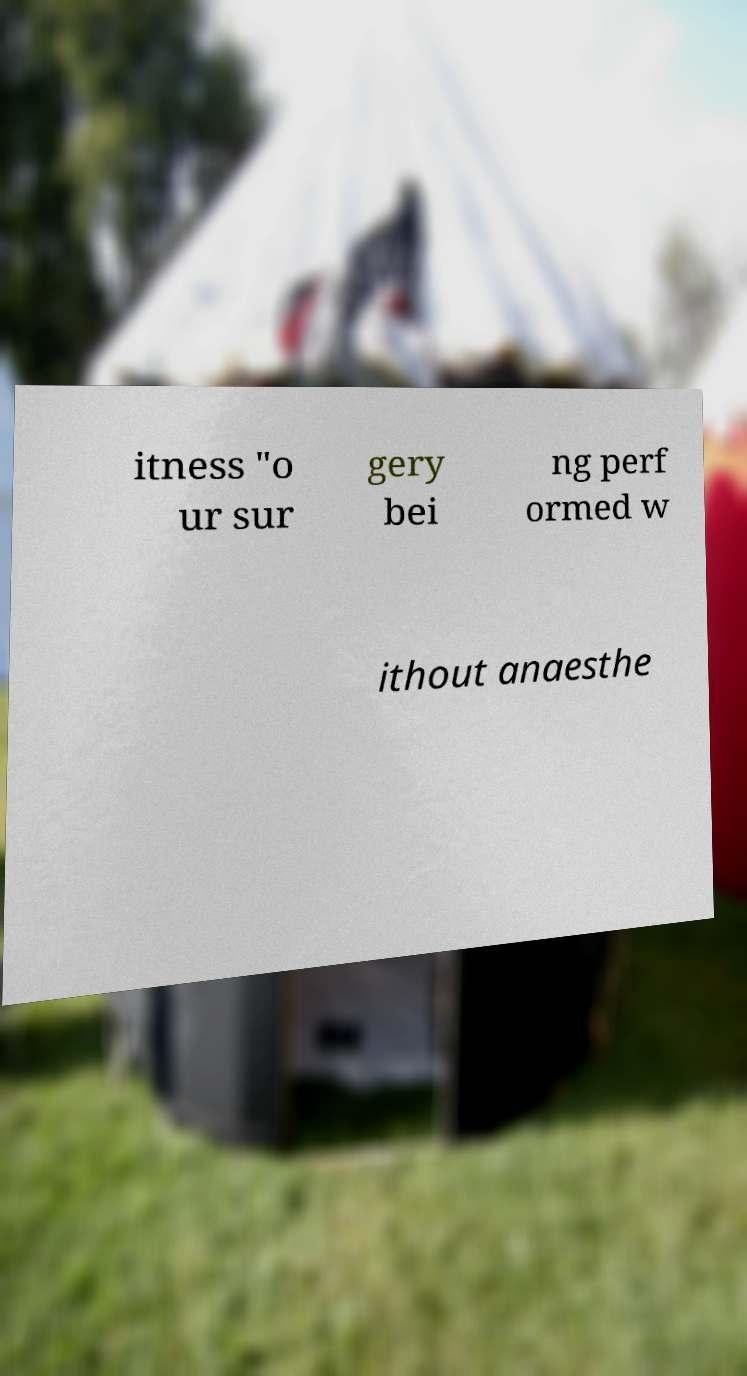Could you extract and type out the text from this image? itness "o ur sur gery bei ng perf ormed w ithout anaesthe 